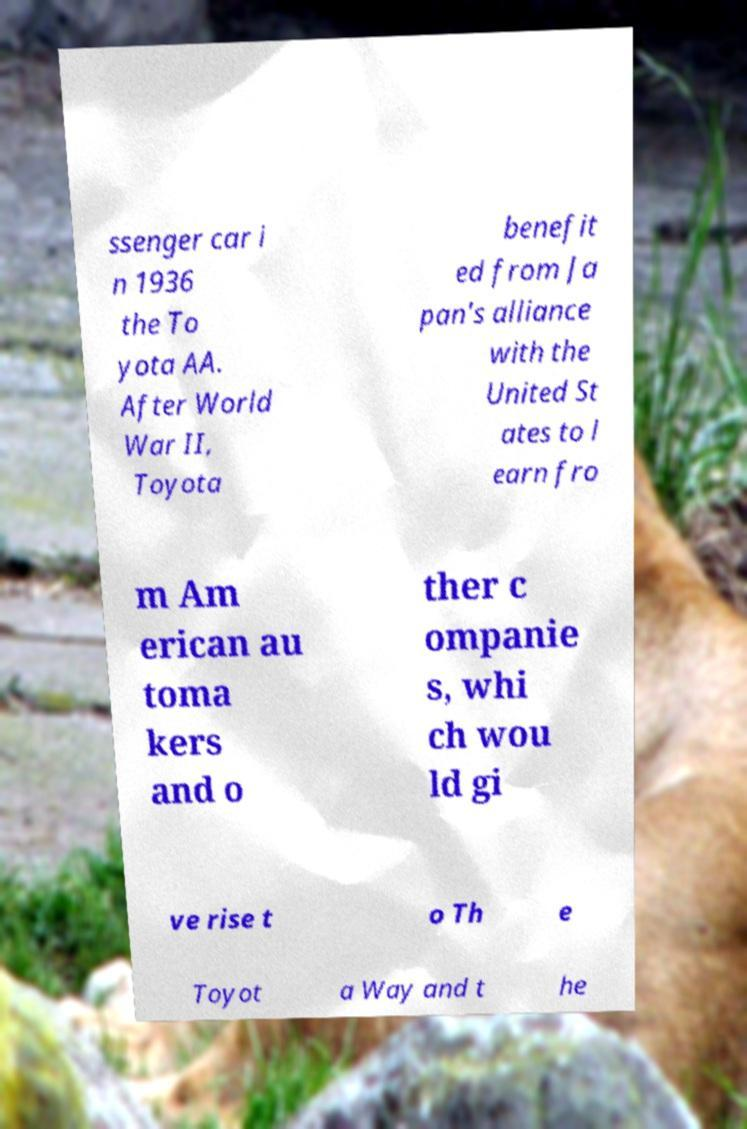There's text embedded in this image that I need extracted. Can you transcribe it verbatim? ssenger car i n 1936 the To yota AA. After World War II, Toyota benefit ed from Ja pan's alliance with the United St ates to l earn fro m Am erican au toma kers and o ther c ompanie s, whi ch wou ld gi ve rise t o Th e Toyot a Way and t he 